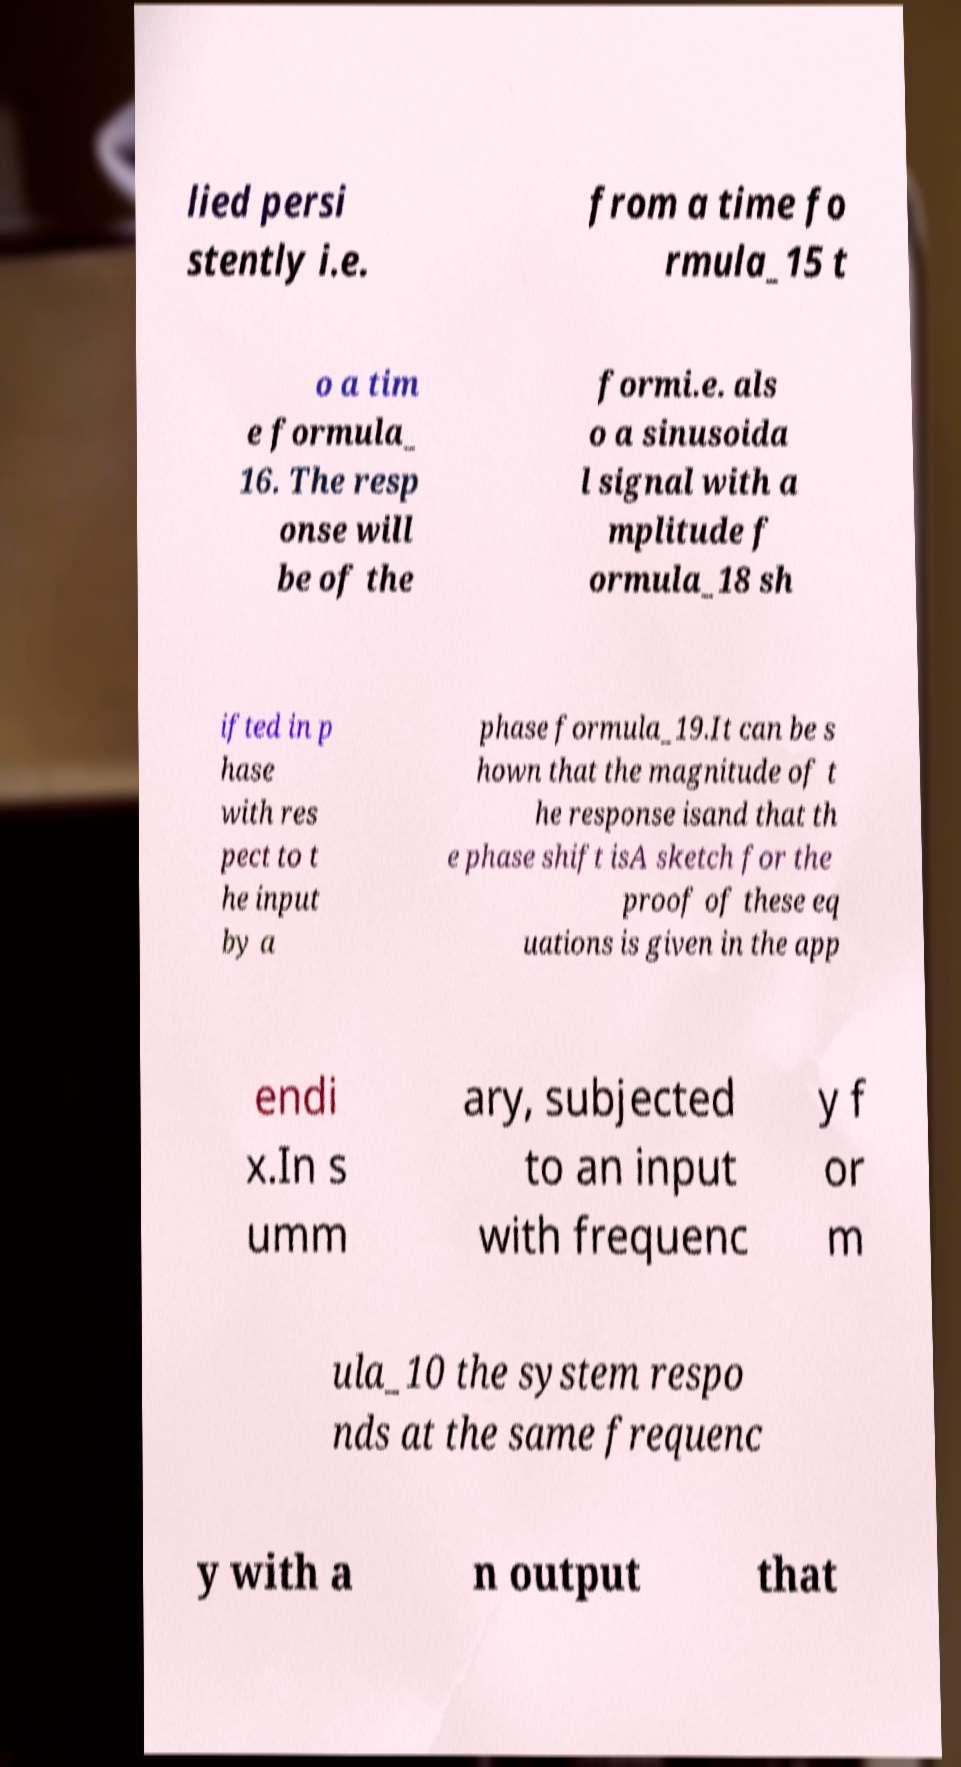Can you accurately transcribe the text from the provided image for me? lied persi stently i.e. from a time fo rmula_15 t o a tim e formula_ 16. The resp onse will be of the formi.e. als o a sinusoida l signal with a mplitude f ormula_18 sh ifted in p hase with res pect to t he input by a phase formula_19.It can be s hown that the magnitude of t he response isand that th e phase shift isA sketch for the proof of these eq uations is given in the app endi x.In s umm ary, subjected to an input with frequenc y f or m ula_10 the system respo nds at the same frequenc y with a n output that 